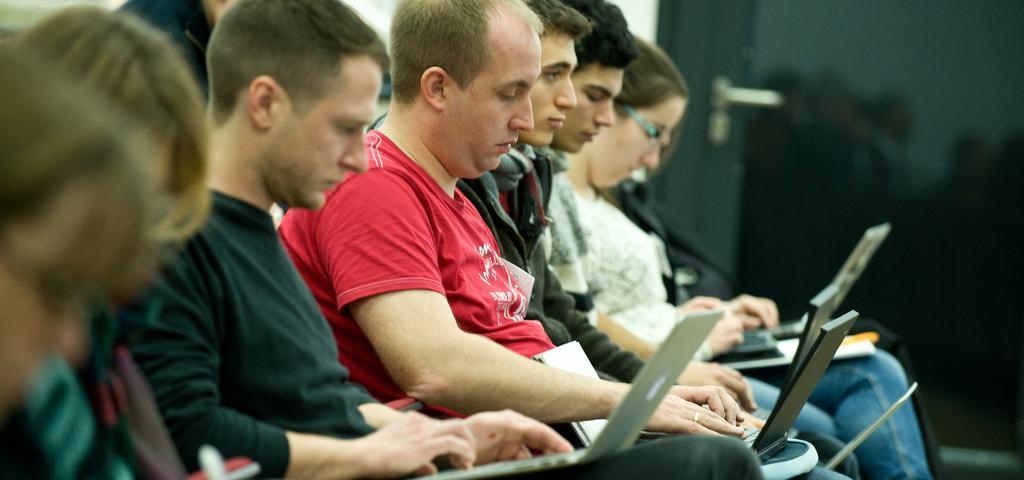Can you describe this image briefly? In this image there are people sitting on chairs and keeping laptops in their laps, in the background it is blurred. 